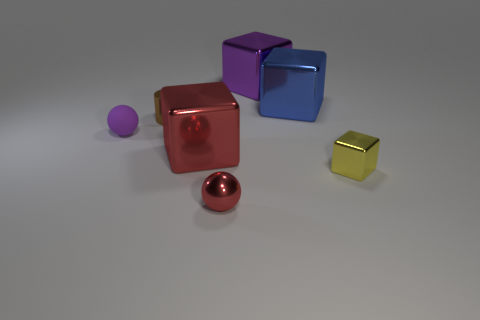Subtract all big shiny blocks. How many blocks are left? 1 Add 2 metallic blocks. How many objects exist? 9 Subtract all purple blocks. How many blocks are left? 3 Subtract 2 cubes. How many cubes are left? 2 Subtract 0 brown balls. How many objects are left? 7 Subtract all cubes. How many objects are left? 3 Subtract all yellow cylinders. Subtract all purple blocks. How many cylinders are left? 1 Subtract all cyan matte cylinders. Subtract all red shiny blocks. How many objects are left? 6 Add 1 large objects. How many large objects are left? 4 Add 6 brown blocks. How many brown blocks exist? 6 